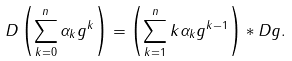Convert formula to latex. <formula><loc_0><loc_0><loc_500><loc_500>D \left ( \sum _ { k = 0 } ^ { n } \alpha _ { k } g ^ { k } \right ) = \left ( \sum _ { k = 1 } ^ { n } k \alpha _ { k } g ^ { k - 1 } \right ) * D g .</formula> 